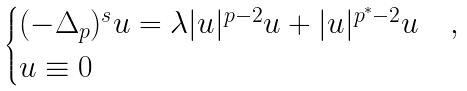Convert formula to latex. <formula><loc_0><loc_0><loc_500><loc_500>\begin{cases} ( - \Delta _ { p } ) ^ { s } u = \lambda | u | ^ { p - 2 } u + | u | ^ { p ^ { * } - 2 } u & , \\ u \equiv 0 & \end{cases}</formula> 